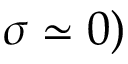Convert formula to latex. <formula><loc_0><loc_0><loc_500><loc_500>\sigma \simeq 0 )</formula> 